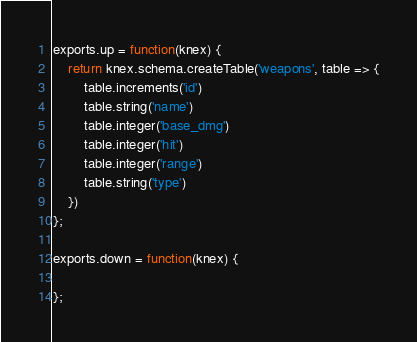Convert code to text. <code><loc_0><loc_0><loc_500><loc_500><_JavaScript_>
exports.up = function(knex) {
	return knex.schema.createTable('weapons', table => {
		table.increments('id')
		table.string('name')
		table.integer('base_dmg')
		table.integer('hit')
		table.integer('range')
		table.string('type')
	})
};

exports.down = function(knex) {
  
};
</code> 